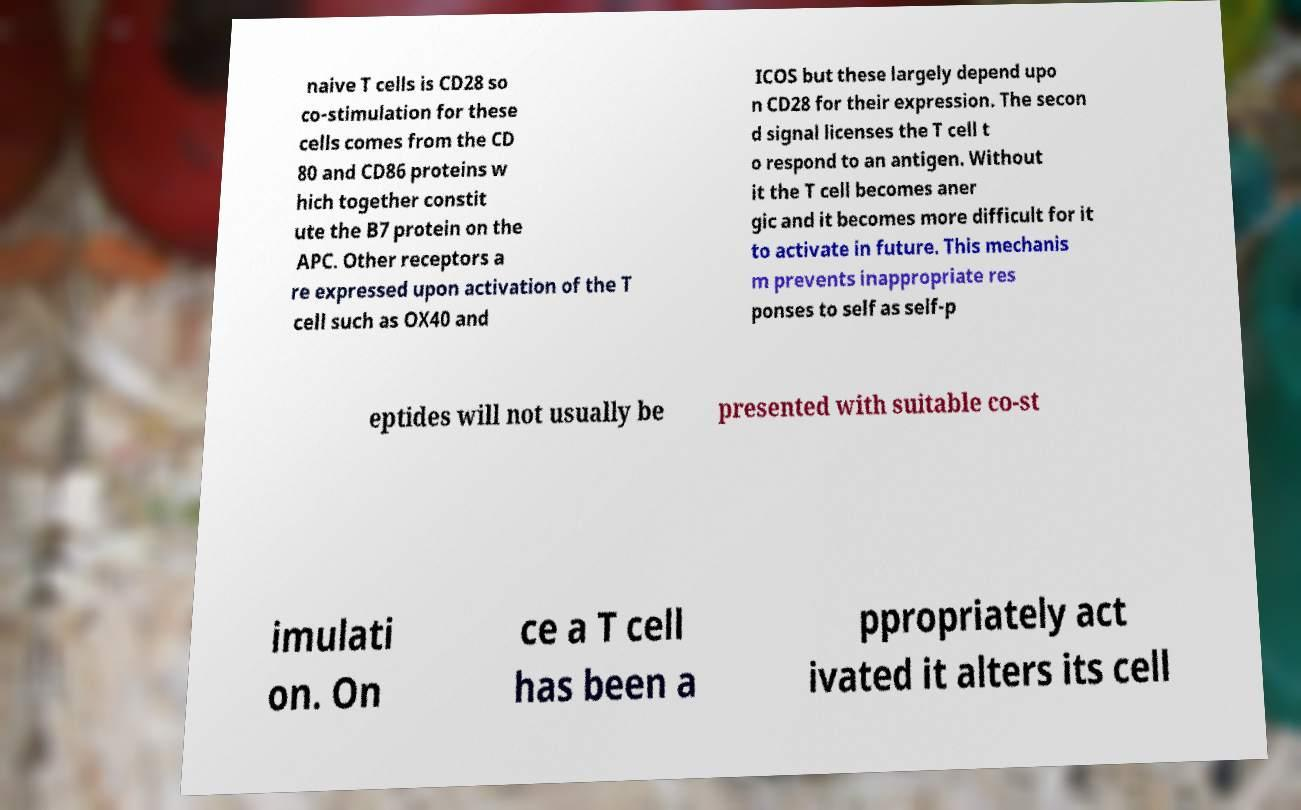Can you accurately transcribe the text from the provided image for me? naive T cells is CD28 so co-stimulation for these cells comes from the CD 80 and CD86 proteins w hich together constit ute the B7 protein on the APC. Other receptors a re expressed upon activation of the T cell such as OX40 and ICOS but these largely depend upo n CD28 for their expression. The secon d signal licenses the T cell t o respond to an antigen. Without it the T cell becomes aner gic and it becomes more difficult for it to activate in future. This mechanis m prevents inappropriate res ponses to self as self-p eptides will not usually be presented with suitable co-st imulati on. On ce a T cell has been a ppropriately act ivated it alters its cell 